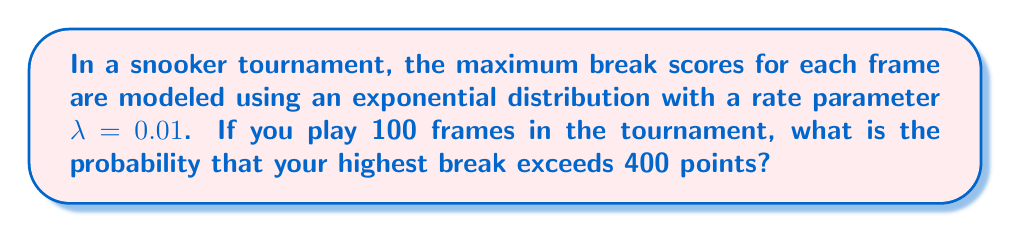Help me with this question. Let's approach this step-by-step:

1) First, we need to understand what the question is asking. We're looking for the probability that the maximum of 100 independent exponentially distributed random variables exceeds 400.

2) The cumulative distribution function (CDF) of an exponential distribution with rate $\lambda$ is:

   $F(x) = 1 - e^{-\lambda x}$ for $x \geq 0$

3) The probability that a single break score exceeds 400 is:

   $P(X > 400) = 1 - P(X \leq 400) = 1 - F(400) = e^{-\lambda \cdot 400}$

4) Substituting $\lambda = 0.01$:

   $P(X > 400) = e^{-0.01 \cdot 400} = e^{-4} \approx 0.0183$

5) Now, for the maximum of 100 independent trials to be 400 or less, all 100 trials must be 400 or less. The probability of this is:

   $P(\text{max} \leq 400) = (1 - e^{-4})^{100}$

6) Therefore, the probability that the maximum exceeds 400 is:

   $P(\text{max} > 400) = 1 - (1 - e^{-4})^{100}$

7) Calculate this value:

   $1 - (1 - e^{-4})^{100} \approx 0.8389$
Answer: $1 - (1 - e^{-4})^{100} \approx 0.8389$ 